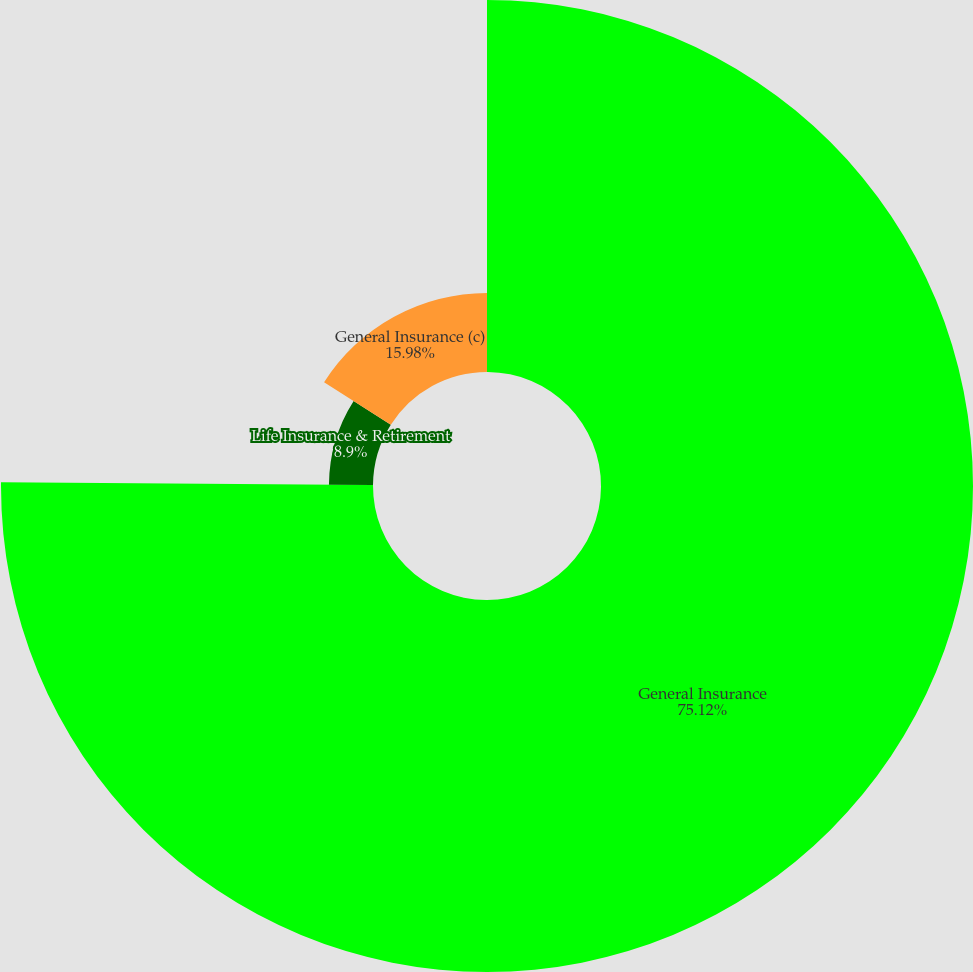<chart> <loc_0><loc_0><loc_500><loc_500><pie_chart><fcel>General Insurance<fcel>Life Insurance & Retirement<fcel>General Insurance (c)<nl><fcel>75.13%<fcel>8.9%<fcel>15.98%<nl></chart> 